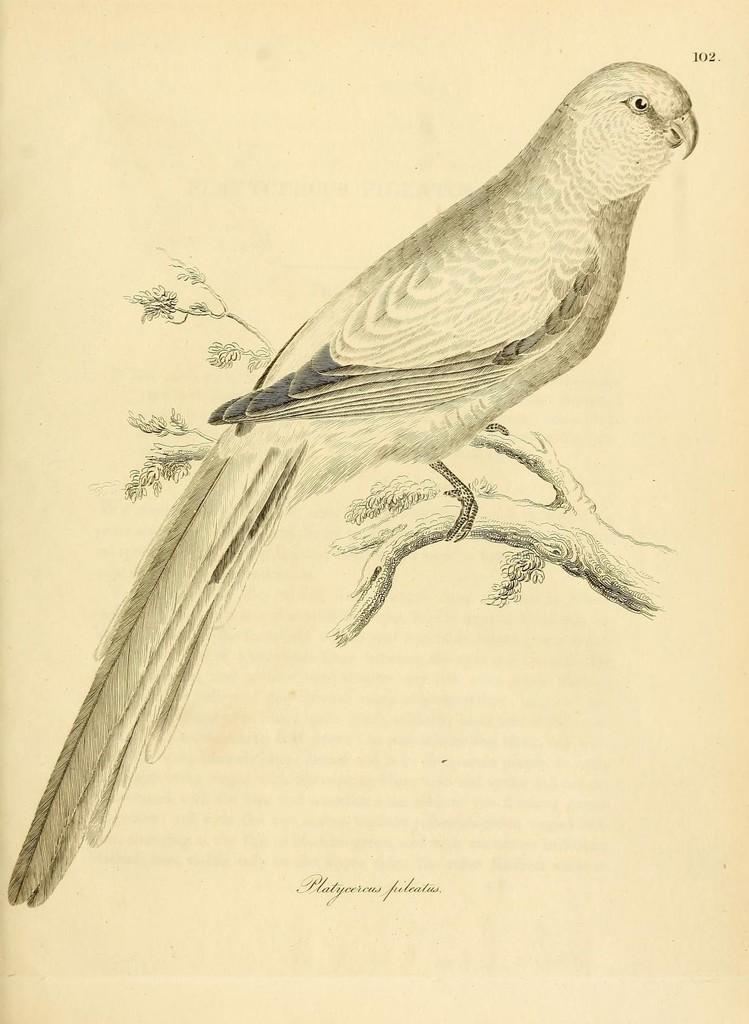What is depicted in the image? There is a sketch of a parrot in the image. What is the medium for the parrot sketch? The sketch is on a steam. Is there any text present in the image? Yes, there is some text at the bottom of the image. How many kitties are sitting on the pies in the image? There are no kitties or pies present in the image; it features a sketch of a parrot on a steam with some text at the bottom. What is the weight of the parrot in the image? The weight of the parrot cannot be determined from the image, as it is a sketch and not a photograph. 